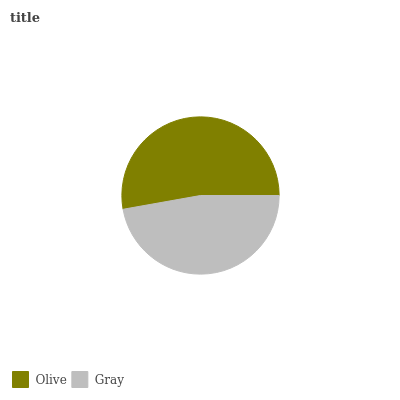Is Gray the minimum?
Answer yes or no. Yes. Is Olive the maximum?
Answer yes or no. Yes. Is Gray the maximum?
Answer yes or no. No. Is Olive greater than Gray?
Answer yes or no. Yes. Is Gray less than Olive?
Answer yes or no. Yes. Is Gray greater than Olive?
Answer yes or no. No. Is Olive less than Gray?
Answer yes or no. No. Is Olive the high median?
Answer yes or no. Yes. Is Gray the low median?
Answer yes or no. Yes. Is Gray the high median?
Answer yes or no. No. Is Olive the low median?
Answer yes or no. No. 